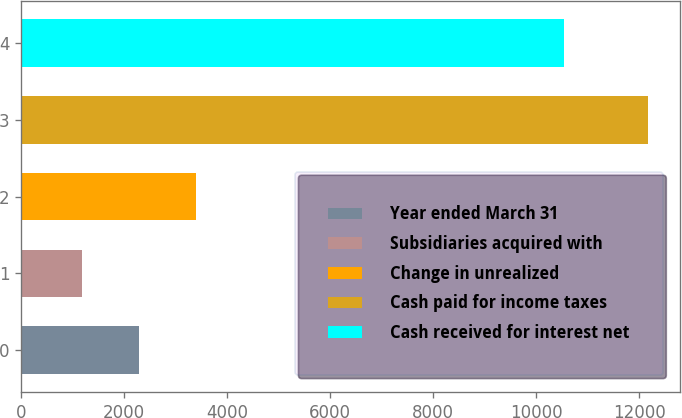Convert chart. <chart><loc_0><loc_0><loc_500><loc_500><bar_chart><fcel>Year ended March 31<fcel>Subsidiaries acquired with<fcel>Change in unrealized<fcel>Cash paid for income taxes<fcel>Cash received for interest net<nl><fcel>2289.7<fcel>1191<fcel>3388.4<fcel>12178<fcel>10543<nl></chart> 